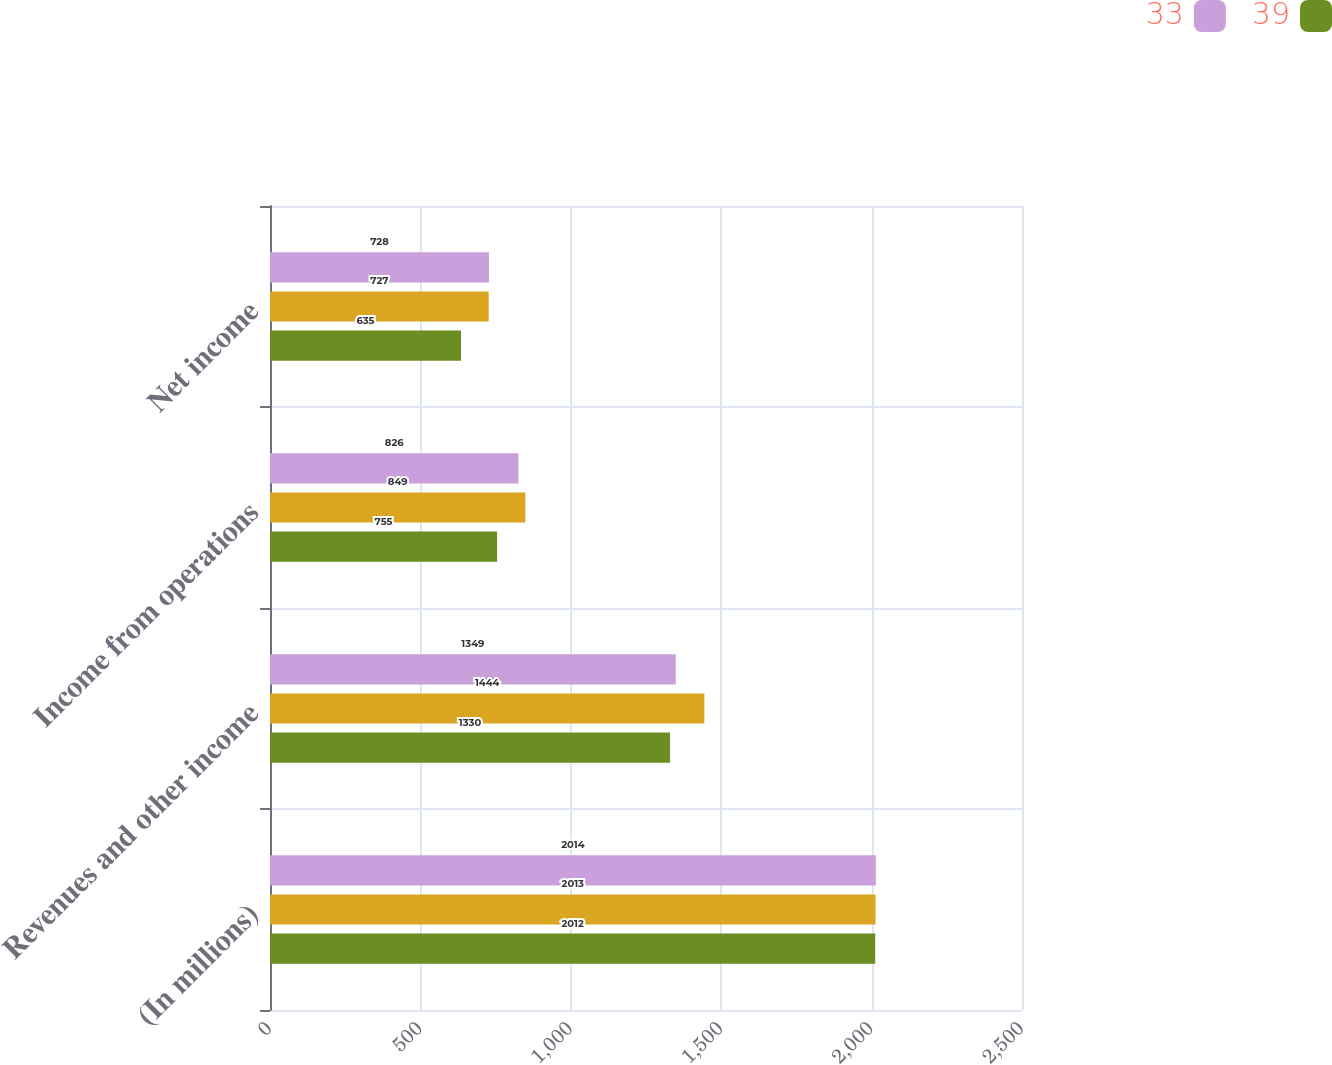Convert chart to OTSL. <chart><loc_0><loc_0><loc_500><loc_500><stacked_bar_chart><ecel><fcel>(In millions)<fcel>Revenues and other income<fcel>Income from operations<fcel>Net income<nl><fcel>33<fcel>2014<fcel>1349<fcel>826<fcel>728<nl><fcel>nan<fcel>2013<fcel>1444<fcel>849<fcel>727<nl><fcel>39<fcel>2012<fcel>1330<fcel>755<fcel>635<nl></chart> 